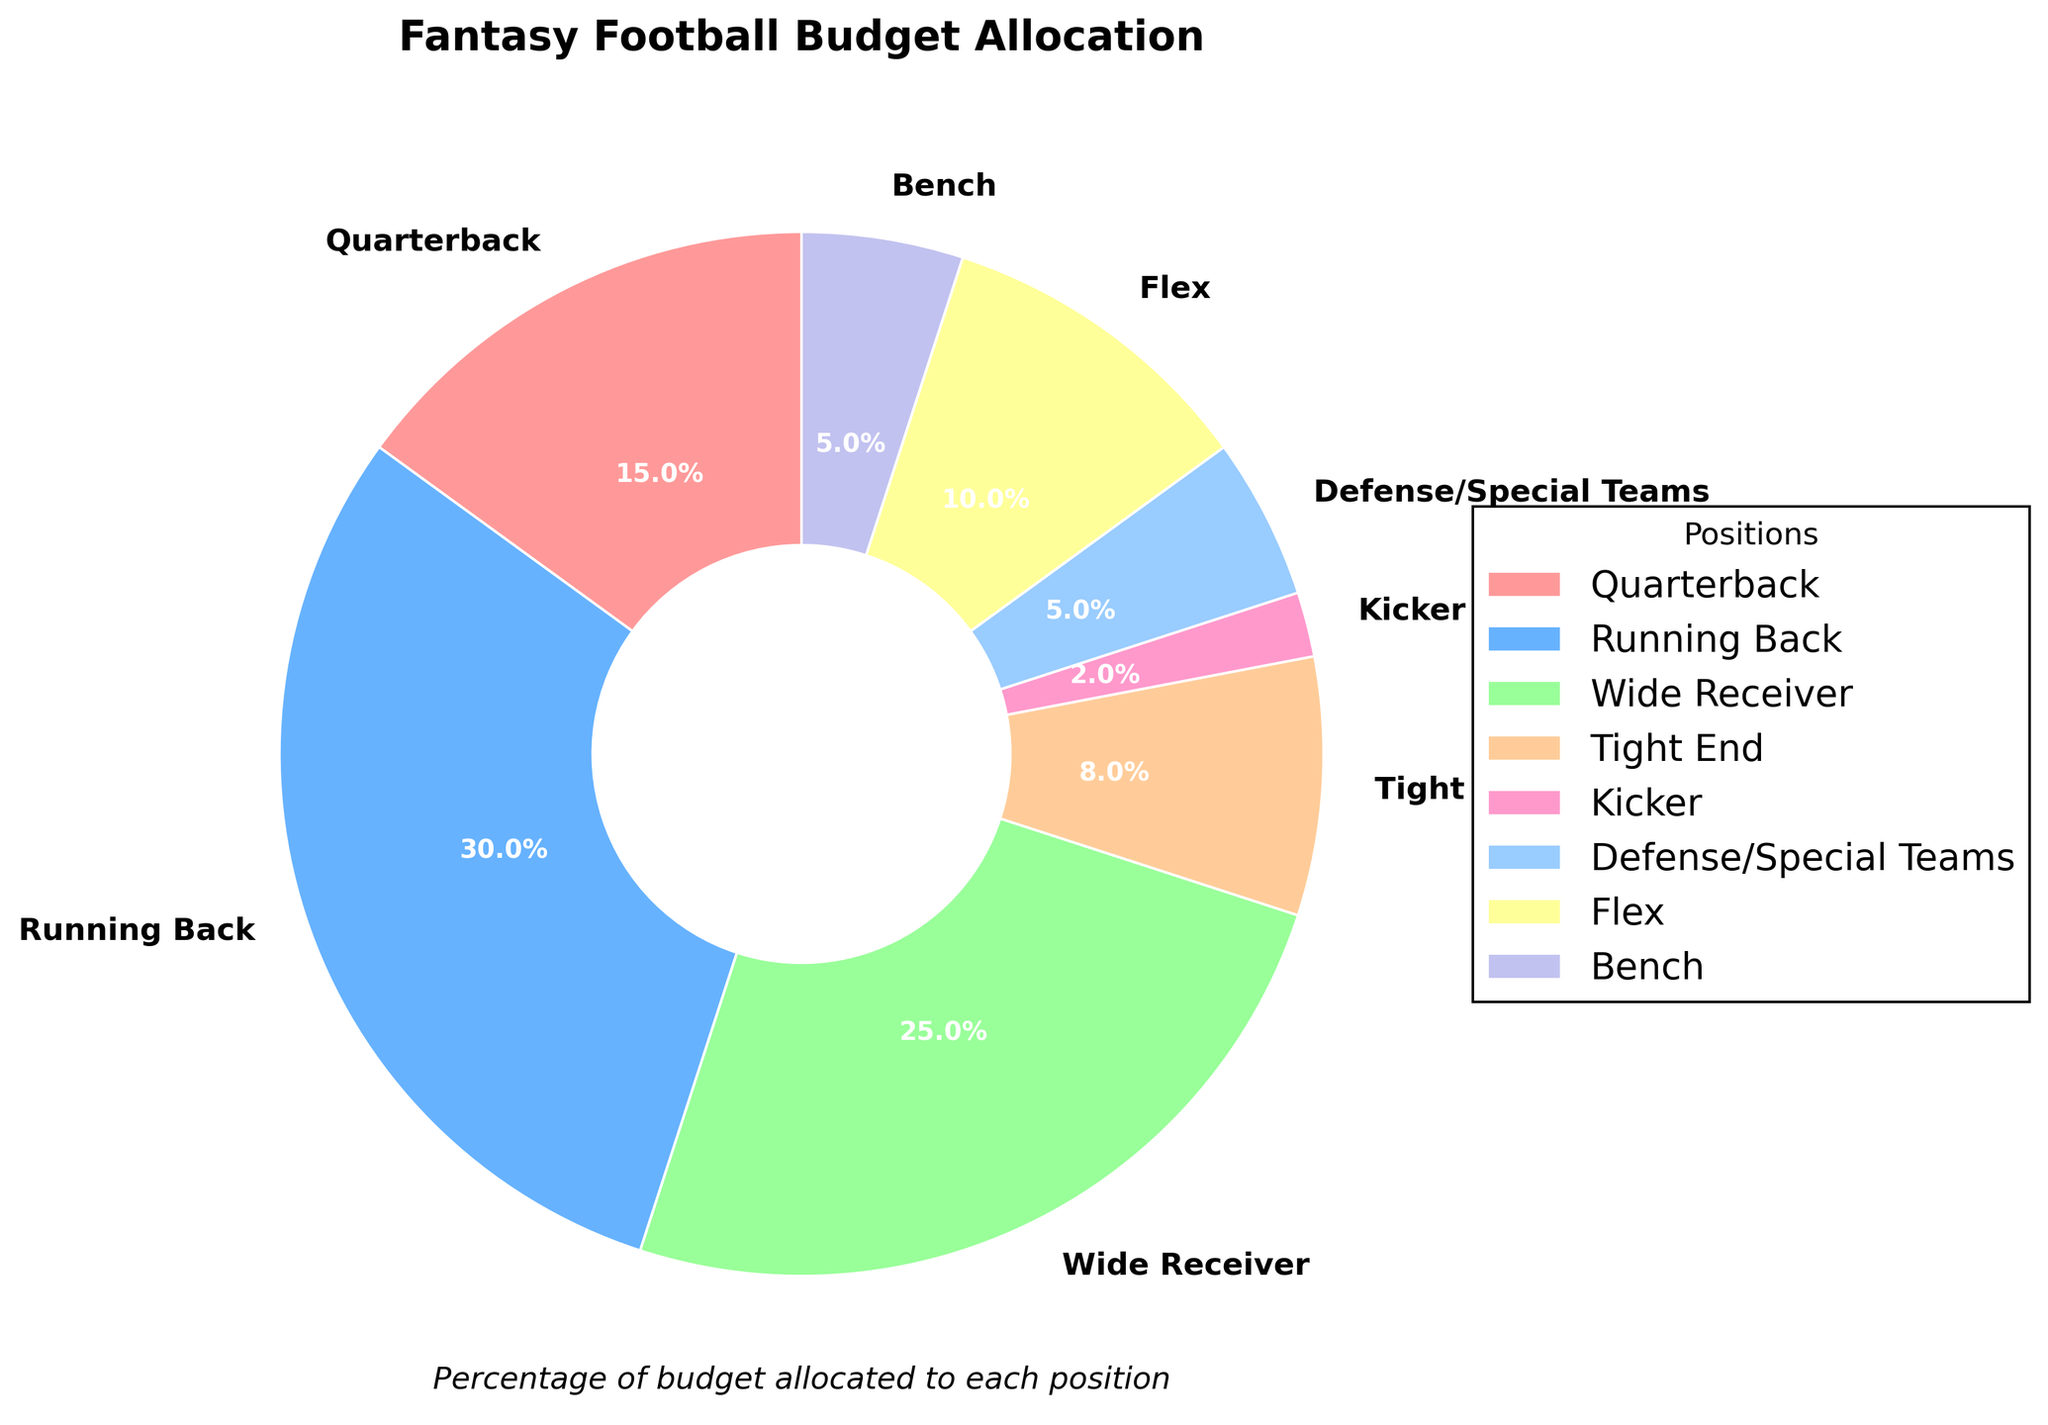What is the largest percentage of budget allocated to a single position? Look at the pie chart and identify the segment with the largest percentage label. The Running Back position has the largest allocation with 30%.
Answer: 30% Which two positions have the smallest combined budget allocation? Find the two segments with the smallest percentages. These are Kicker (2%) and Defense/Special Teams (5%), their combined allocation is 2% + 5% = 7%.
Answer: 7% How much more budget is allocated to the Wide Receiver position compared to the Quarterback position? Compare the percentages of Wide Receiver (25%) and Quarterback (15%). The difference is 25% - 15% = 10%.
Answer: 10% What is the total budget allocation for all offensive positions (Quarterback, Running Back, Wide Receiver, Tight End, and Flex)? Add the percentages of all offensive positions: Quarterback (15%) + Running Back (30%) + Wide Receiver (25%) + Tight End (8%) + Flex (10%) = 88%.
Answer: 88% If the budget allocation for the Bench position were to increase by 3%, what would the new percentage be? Add 3% to the current Bench allocation: 5% + 3% = 8%.
Answer: 8% Which position has the blue-colored pie segment? Identify the color associated with the positions in the pie chart. The blue segment corresponds to the Running Back position.
Answer: Running Back How much more budget is allocated to the Flex position compared to the Kicker position? Compare the percentages of Flex (10%) and Kicker (2%). The difference is 10% - 2% = 8%.
Answer: 8% What is the average budget allocation across all positions? Sum all percentages and divide by the number of positions: (15% + 30% + 25% + 8% + 2% + 5% + 10% + 5%) / 8 = 100% / 8 = 12.5%.
Answer: 12.5% Which position has the thinnest pie segment in the chart? Identify the thinnest segment in the pie chart, which corresponds to the Kicker position with 2%.
Answer: Kicker 